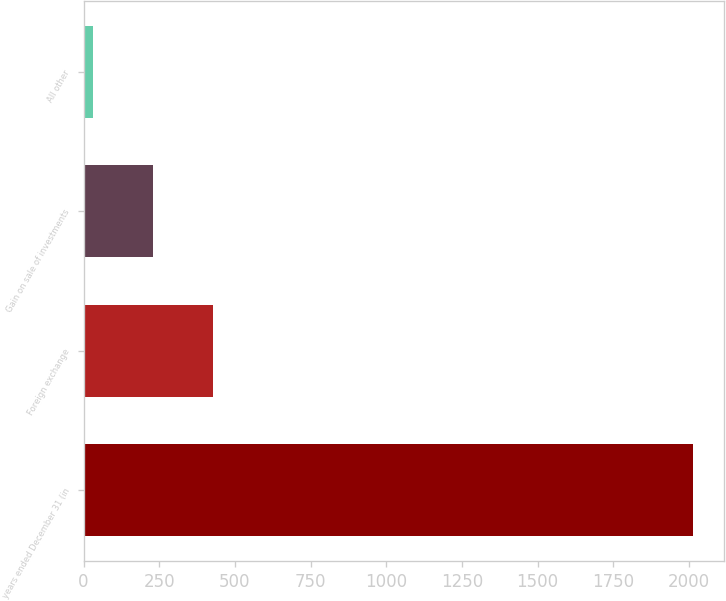<chart> <loc_0><loc_0><loc_500><loc_500><bar_chart><fcel>years ended December 31 (in<fcel>Foreign exchange<fcel>Gain on sale of investments<fcel>All other<nl><fcel>2015<fcel>428.6<fcel>230.3<fcel>32<nl></chart> 